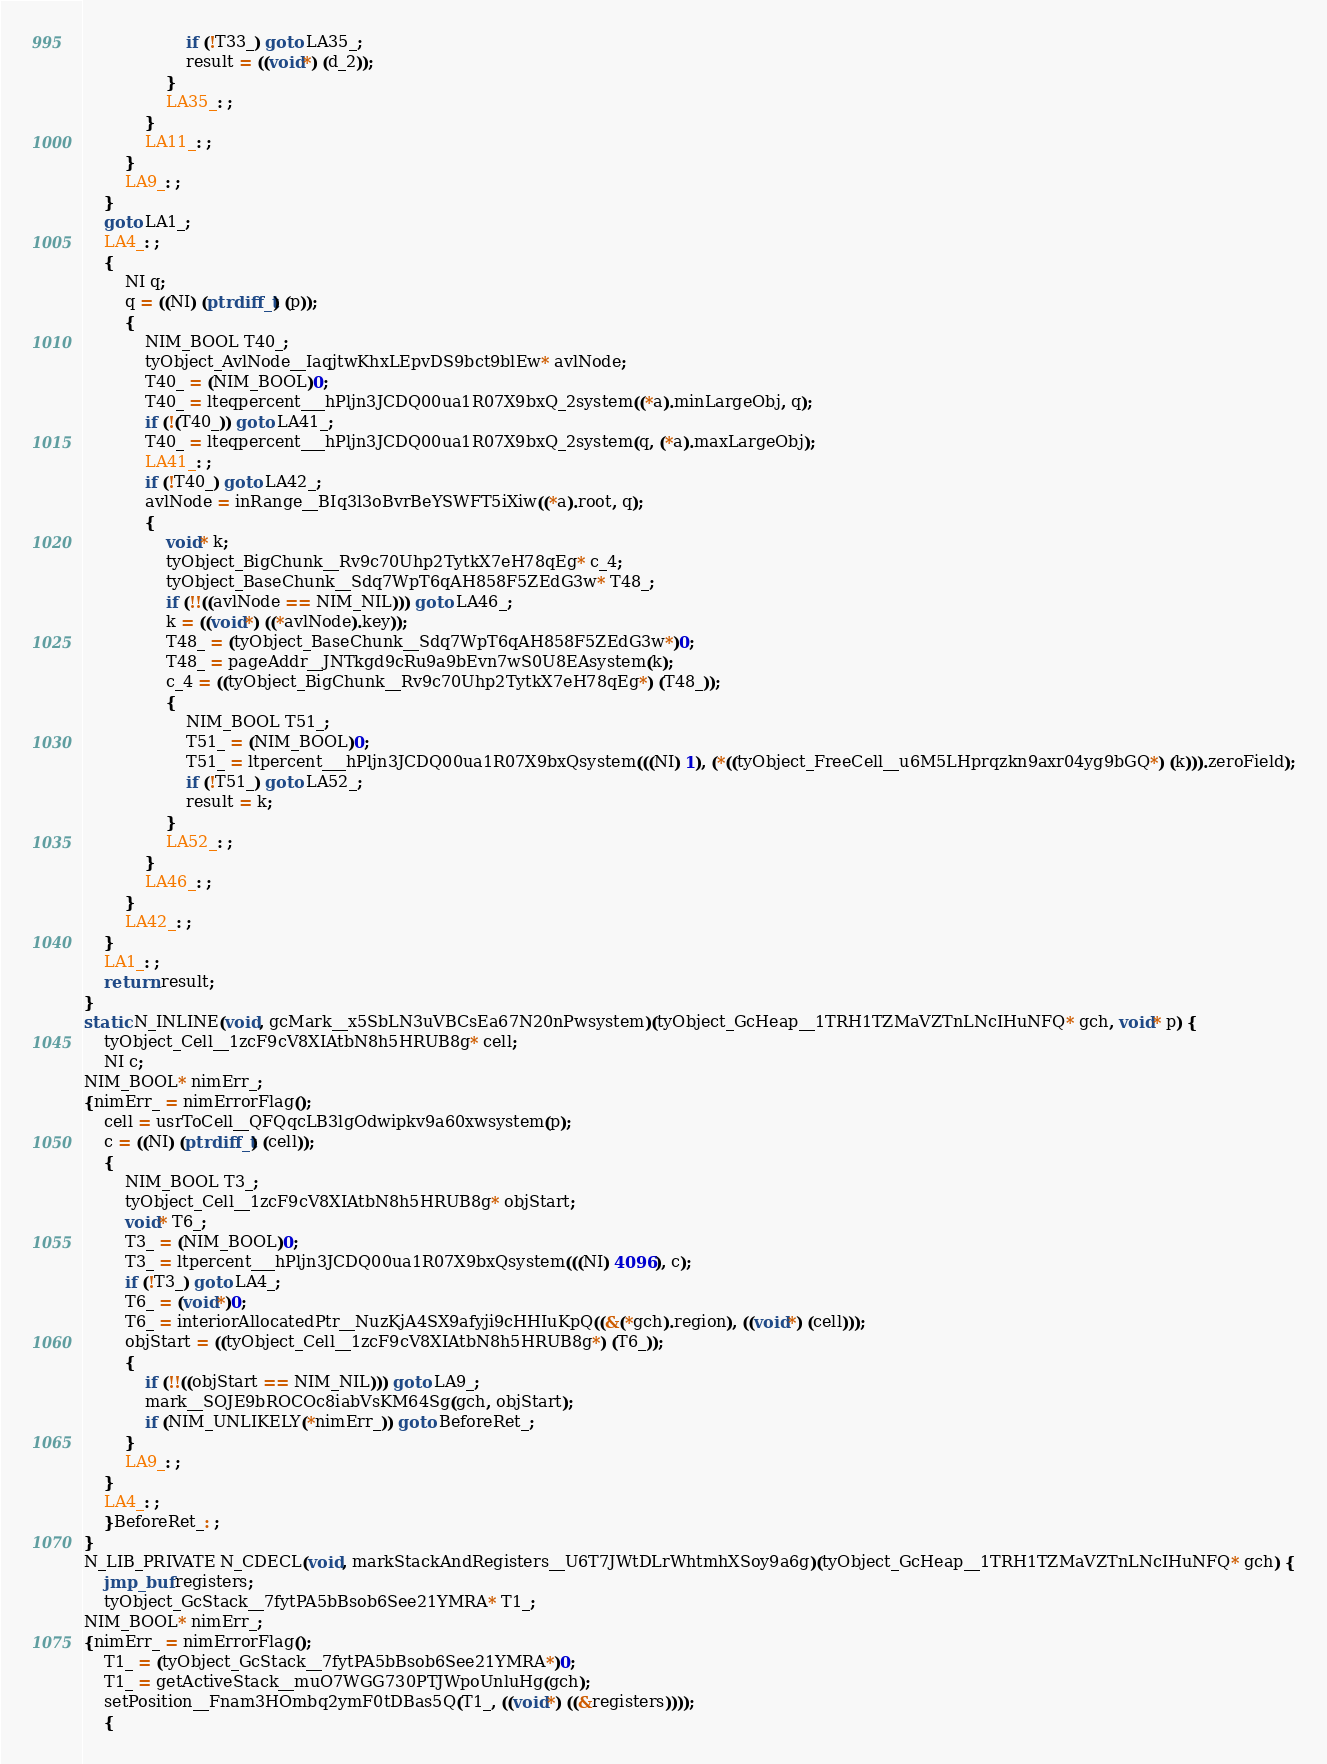Convert code to text. <code><loc_0><loc_0><loc_500><loc_500><_C_>					if (!T33_) goto LA35_;
					result = ((void*) (d_2));
				}
				LA35_: ;
			}
			LA11_: ;
		}
		LA9_: ;
	}
	goto LA1_;
	LA4_: ;
	{
		NI q;
		q = ((NI) (ptrdiff_t) (p));
		{
			NIM_BOOL T40_;
			tyObject_AvlNode__IaqjtwKhxLEpvDS9bct9blEw* avlNode;
			T40_ = (NIM_BOOL)0;
			T40_ = lteqpercent___hPljn3JCDQ00ua1R07X9bxQ_2system((*a).minLargeObj, q);
			if (!(T40_)) goto LA41_;
			T40_ = lteqpercent___hPljn3JCDQ00ua1R07X9bxQ_2system(q, (*a).maxLargeObj);
			LA41_: ;
			if (!T40_) goto LA42_;
			avlNode = inRange__BIq3l3oBvrBeYSWFT5iXiw((*a).root, q);
			{
				void* k;
				tyObject_BigChunk__Rv9c70Uhp2TytkX7eH78qEg* c_4;
				tyObject_BaseChunk__Sdq7WpT6qAH858F5ZEdG3w* T48_;
				if (!!((avlNode == NIM_NIL))) goto LA46_;
				k = ((void*) ((*avlNode).key));
				T48_ = (tyObject_BaseChunk__Sdq7WpT6qAH858F5ZEdG3w*)0;
				T48_ = pageAddr__JNTkgd9cRu9a9bEvn7wS0U8EAsystem(k);
				c_4 = ((tyObject_BigChunk__Rv9c70Uhp2TytkX7eH78qEg*) (T48_));
				{
					NIM_BOOL T51_;
					T51_ = (NIM_BOOL)0;
					T51_ = ltpercent___hPljn3JCDQ00ua1R07X9bxQsystem(((NI) 1), (*((tyObject_FreeCell__u6M5LHprqzkn9axr04yg9bGQ*) (k))).zeroField);
					if (!T51_) goto LA52_;
					result = k;
				}
				LA52_: ;
			}
			LA46_: ;
		}
		LA42_: ;
	}
	LA1_: ;
	return result;
}
static N_INLINE(void, gcMark__x5SbLN3uVBCsEa67N20nPwsystem)(tyObject_GcHeap__1TRH1TZMaVZTnLNcIHuNFQ* gch, void* p) {
	tyObject_Cell__1zcF9cV8XIAtbN8h5HRUB8g* cell;
	NI c;
NIM_BOOL* nimErr_;
{nimErr_ = nimErrorFlag();
	cell = usrToCell__QFQqcLB3lgOdwipkv9a60xwsystem(p);
	c = ((NI) (ptrdiff_t) (cell));
	{
		NIM_BOOL T3_;
		tyObject_Cell__1zcF9cV8XIAtbN8h5HRUB8g* objStart;
		void* T6_;
		T3_ = (NIM_BOOL)0;
		T3_ = ltpercent___hPljn3JCDQ00ua1R07X9bxQsystem(((NI) 4096), c);
		if (!T3_) goto LA4_;
		T6_ = (void*)0;
		T6_ = interiorAllocatedPtr__NuzKjA4SX9afyji9cHHIuKpQ((&(*gch).region), ((void*) (cell)));
		objStart = ((tyObject_Cell__1zcF9cV8XIAtbN8h5HRUB8g*) (T6_));
		{
			if (!!((objStart == NIM_NIL))) goto LA9_;
			mark__SOJE9bROCOc8iabVsKM64Sg(gch, objStart);
			if (NIM_UNLIKELY(*nimErr_)) goto BeforeRet_;
		}
		LA9_: ;
	}
	LA4_: ;
	}BeforeRet_: ;
}
N_LIB_PRIVATE N_CDECL(void, markStackAndRegisters__U6T7JWtDLrWhtmhXSoy9a6g)(tyObject_GcHeap__1TRH1TZMaVZTnLNcIHuNFQ* gch) {
	jmp_buf registers;
	tyObject_GcStack__7fytPA5bBsob6See21YMRA* T1_;
NIM_BOOL* nimErr_;
{nimErr_ = nimErrorFlag();
	T1_ = (tyObject_GcStack__7fytPA5bBsob6See21YMRA*)0;
	T1_ = getActiveStack__muO7WGG730PTJWpoUnluHg(gch);
	setPosition__Fnam3HOmbq2ymF0tDBas5Q(T1_, ((void*) ((&registers))));
	{</code> 